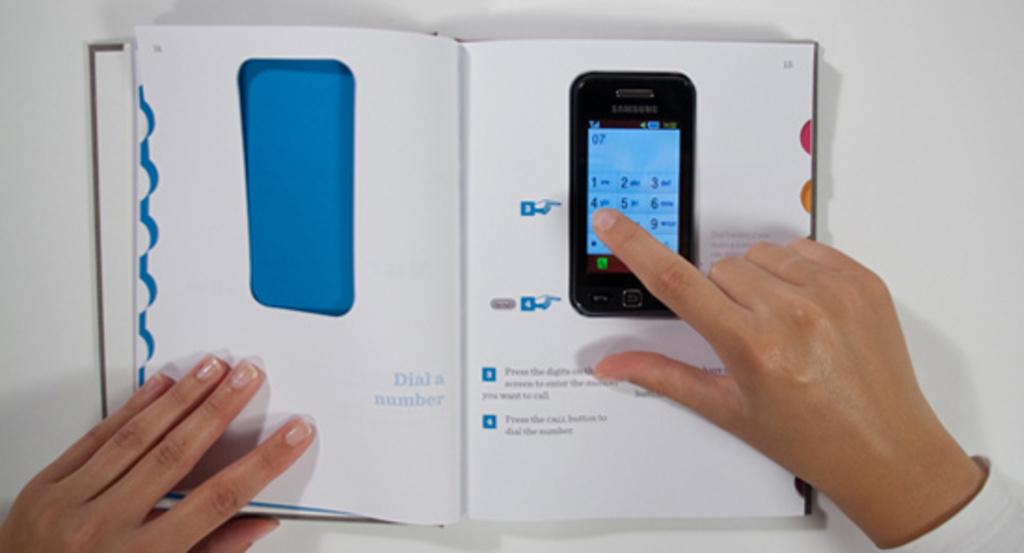<image>
Write a terse but informative summary of the picture. A person is reading a book that shows a Samsung cellphone on the page they are touching. 